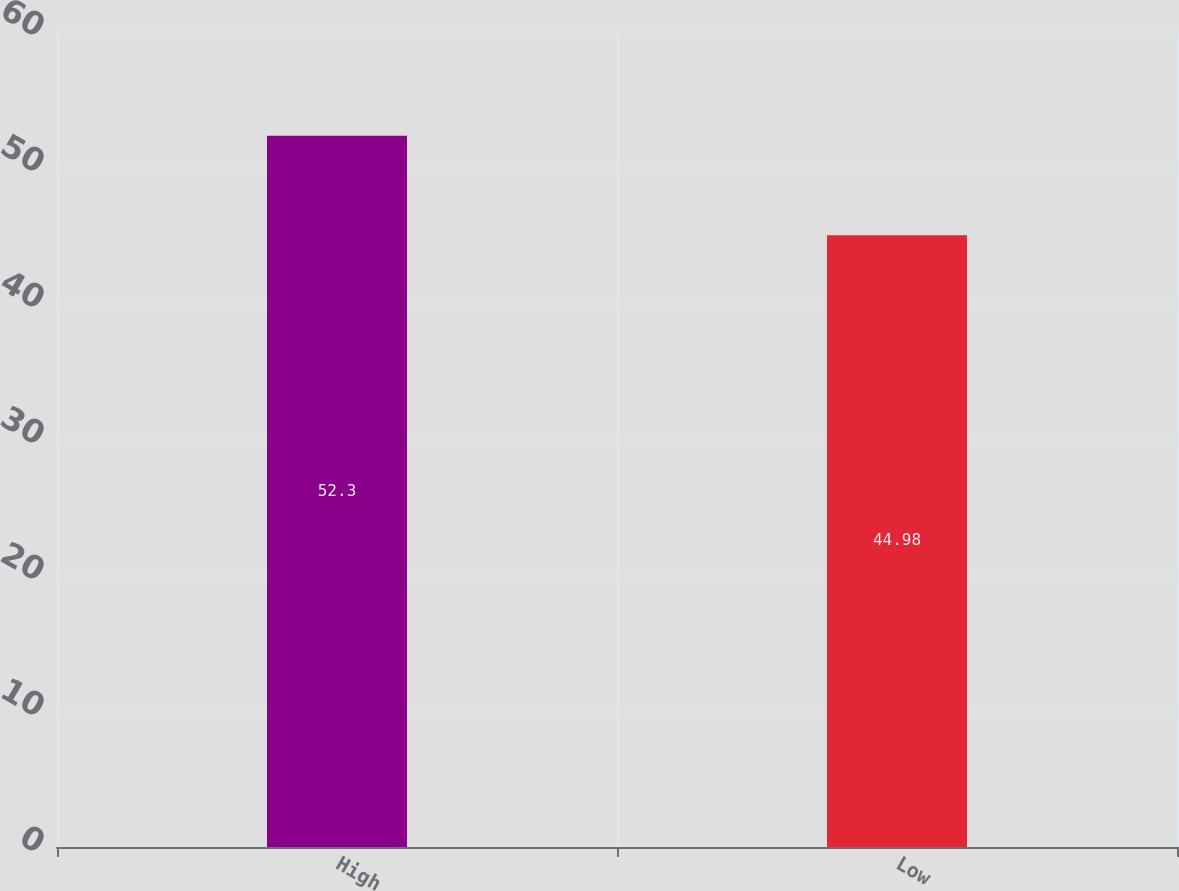<chart> <loc_0><loc_0><loc_500><loc_500><bar_chart><fcel>High<fcel>Low<nl><fcel>52.3<fcel>44.98<nl></chart> 